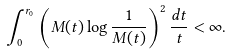<formula> <loc_0><loc_0><loc_500><loc_500>\int _ { 0 } ^ { r _ { 0 } } \left ( M ( t ) \log \frac { 1 } { M ( t ) } \right ) ^ { 2 } \frac { d t } { t } < \infty .</formula> 